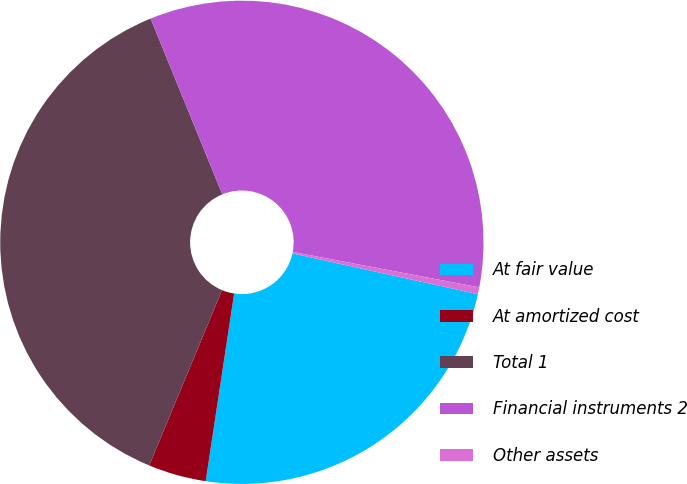Convert chart to OTSL. <chart><loc_0><loc_0><loc_500><loc_500><pie_chart><fcel>At fair value<fcel>At amortized cost<fcel>Total 1<fcel>Financial instruments 2<fcel>Other assets<nl><fcel>23.95%<fcel>3.87%<fcel>37.57%<fcel>34.15%<fcel>0.46%<nl></chart> 